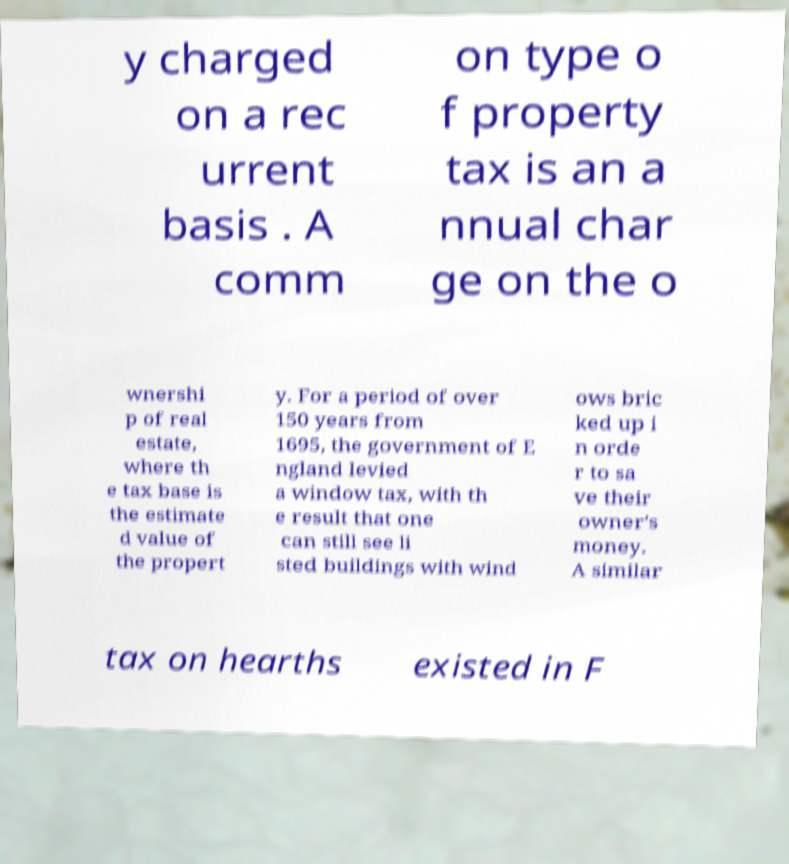Could you extract and type out the text from this image? y charged on a rec urrent basis . A comm on type o f property tax is an a nnual char ge on the o wnershi p of real estate, where th e tax base is the estimate d value of the propert y. For a period of over 150 years from 1695, the government of E ngland levied a window tax, with th e result that one can still see li sted buildings with wind ows bric ked up i n orde r to sa ve their owner's money. A similar tax on hearths existed in F 